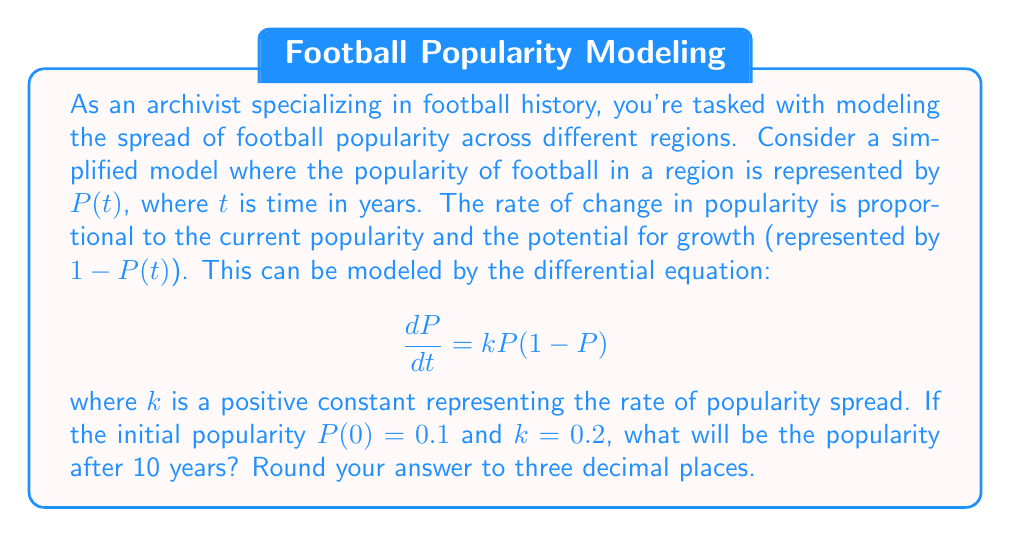Help me with this question. To solve this problem, we need to follow these steps:

1) First, we recognize this differential equation as the logistic growth model.

2) The solution to this equation is given by:

   $$P(t) = \frac{1}{1 + (\frac{1}{P_0} - 1)e^{-kt}}$$

   where $P_0$ is the initial popularity.

3) We're given that $P_0 = 0.1$, $k = 0.2$, and we need to find $P(10)$.

4) Let's substitute these values into our equation:

   $$P(10) = \frac{1}{1 + (\frac{1}{0.1} - 1)e^{-0.2(10)}}$$

5) Simplify the fraction inside the parentheses:

   $$P(10) = \frac{1}{1 + (10 - 1)e^{-2}}$$

6) Calculate $e^{-2}$:

   $$P(10) = \frac{1}{1 + 9 \cdot 0.1353}$$

7) Multiply inside the parentheses:

   $$P(10) = \frac{1}{1 + 1.2177}$$

8) Add in the denominator:

   $$P(10) = \frac{1}{2.2177}$$

9) Divide:

   $$P(10) \approx 0.4509$$

10) Rounding to three decimal places:

    $$P(10) \approx 0.451$$
Answer: 0.451 